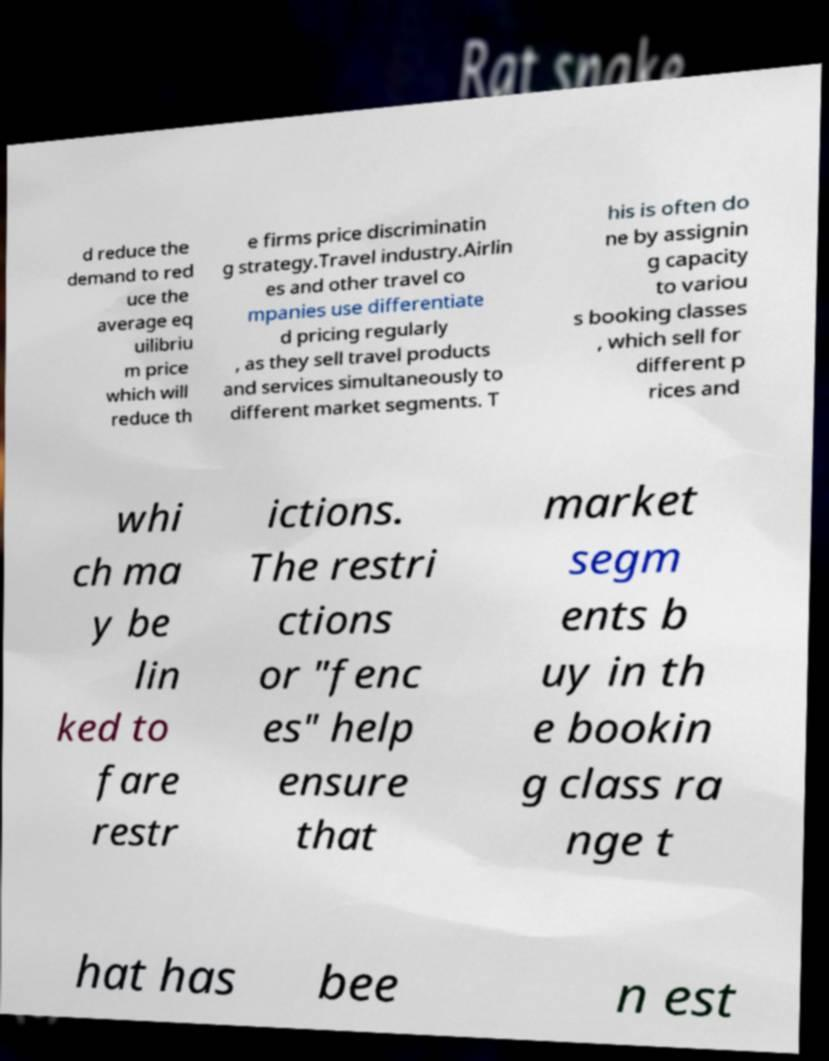Please read and relay the text visible in this image. What does it say? d reduce the demand to red uce the average eq uilibriu m price which will reduce th e firms price discriminatin g strategy.Travel industry.Airlin es and other travel co mpanies use differentiate d pricing regularly , as they sell travel products and services simultaneously to different market segments. T his is often do ne by assignin g capacity to variou s booking classes , which sell for different p rices and whi ch ma y be lin ked to fare restr ictions. The restri ctions or "fenc es" help ensure that market segm ents b uy in th e bookin g class ra nge t hat has bee n est 